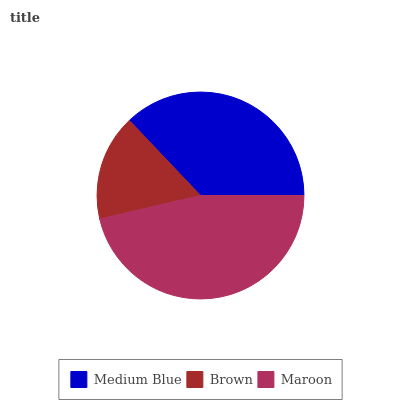Is Brown the minimum?
Answer yes or no. Yes. Is Maroon the maximum?
Answer yes or no. Yes. Is Maroon the minimum?
Answer yes or no. No. Is Brown the maximum?
Answer yes or no. No. Is Maroon greater than Brown?
Answer yes or no. Yes. Is Brown less than Maroon?
Answer yes or no. Yes. Is Brown greater than Maroon?
Answer yes or no. No. Is Maroon less than Brown?
Answer yes or no. No. Is Medium Blue the high median?
Answer yes or no. Yes. Is Medium Blue the low median?
Answer yes or no. Yes. Is Brown the high median?
Answer yes or no. No. Is Brown the low median?
Answer yes or no. No. 